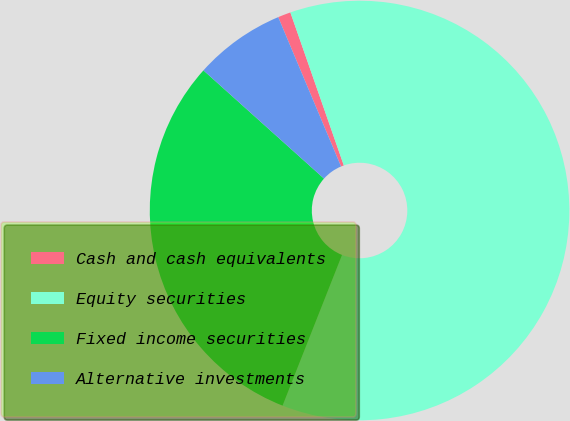Convert chart. <chart><loc_0><loc_0><loc_500><loc_500><pie_chart><fcel>Cash and cash equivalents<fcel>Equity securities<fcel>Fixed income securities<fcel>Alternative investments<nl><fcel>0.99%<fcel>61.33%<fcel>30.66%<fcel>7.02%<nl></chart> 